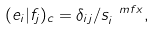Convert formula to latex. <formula><loc_0><loc_0><loc_500><loc_500>( e _ { i } | f _ { j } ) _ { c } = \delta _ { i j } / s ^ { \ m f { x } } _ { i } ,</formula> 